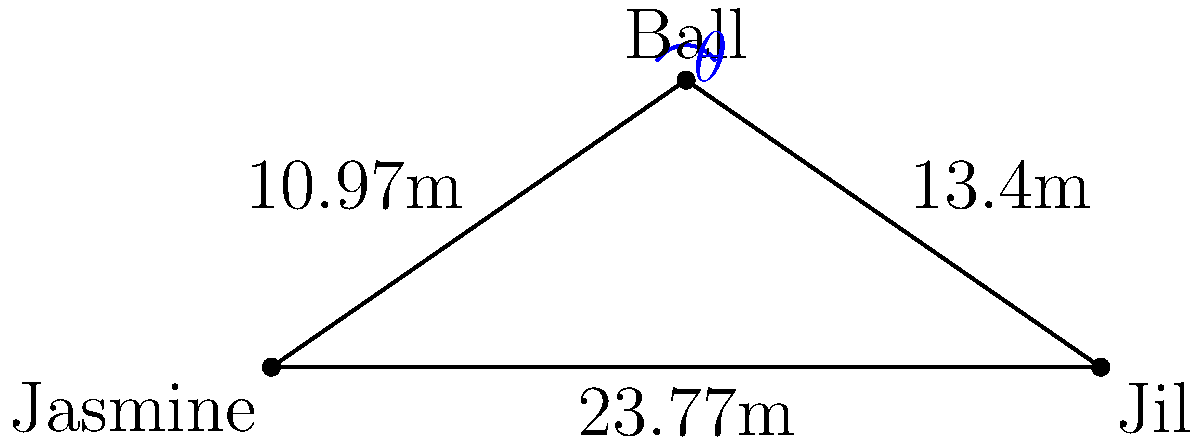During a match between Jasmine Paolini and Jil Teichmann, the ball lands at a specific point on the court. Jasmine is 10.97m away from the ball, while Jil is 13.4m away. If the width of the tennis court is 23.77m, what is the angle $\theta$ (in degrees) between the two lines connecting the ball to each player? To solve this problem, we'll use the law of cosines. Let's follow these steps:

1) Let's define our variables:
   a = 10.97m (distance from Jasmine to the ball)
   b = 13.4m (distance from Jil to the ball)
   c = 23.77m (width of the court, distance between players)
   $\theta$ = angle we're looking for

2) The law of cosines states:
   $$c^2 = a^2 + b^2 - 2ab \cos(\theta)$$

3) Rearranging to solve for $\cos(\theta)$:
   $$\cos(\theta) = \frac{a^2 + b^2 - c^2}{2ab}$$

4) Substituting our values:
   $$\cos(\theta) = \frac{10.97^2 + 13.4^2 - 23.77^2}{2(10.97)(13.4)}$$

5) Calculate:
   $$\cos(\theta) = \frac{120.3409 + 179.56 - 564.9129}{293.996}$$
   $$\cos(\theta) = \frac{-265.012}{293.996} \approx -0.9014$$

6) To get $\theta$, we need to take the inverse cosine (arccos):
   $$\theta = \arccos(-0.9014)$$

7) Calculate:
   $$\theta \approx 154.1°$$

Therefore, the angle between the two lines connecting the ball to each player is approximately 154.1°.
Answer: 154.1° 